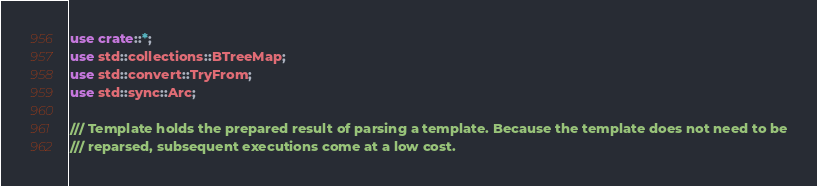<code> <loc_0><loc_0><loc_500><loc_500><_Rust_>use crate::*;
use std::collections::BTreeMap;
use std::convert::TryFrom;
use std::sync::Arc;

/// Template holds the prepared result of parsing a template. Because the template does not need to be
/// reparsed, subsequent executions come at a low cost.</code> 